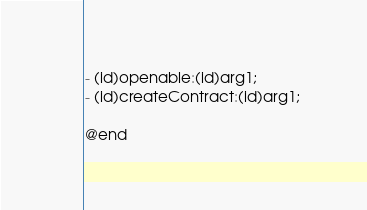Convert code to text. <code><loc_0><loc_0><loc_500><loc_500><_C_>- (id)openable:(id)arg1;
- (id)createContract:(id)arg1;

@end

</code> 